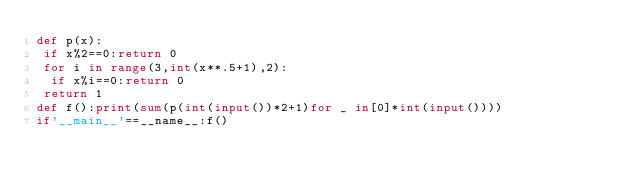Convert code to text. <code><loc_0><loc_0><loc_500><loc_500><_Python_>def p(x):
 if x%2==0:return 0
 for i in range(3,int(x**.5+1),2):
  if x%i==0:return 0
 return 1
def f():print(sum(p(int(input())*2+1)for _ in[0]*int(input())))
if'__main__'==__name__:f()
</code> 